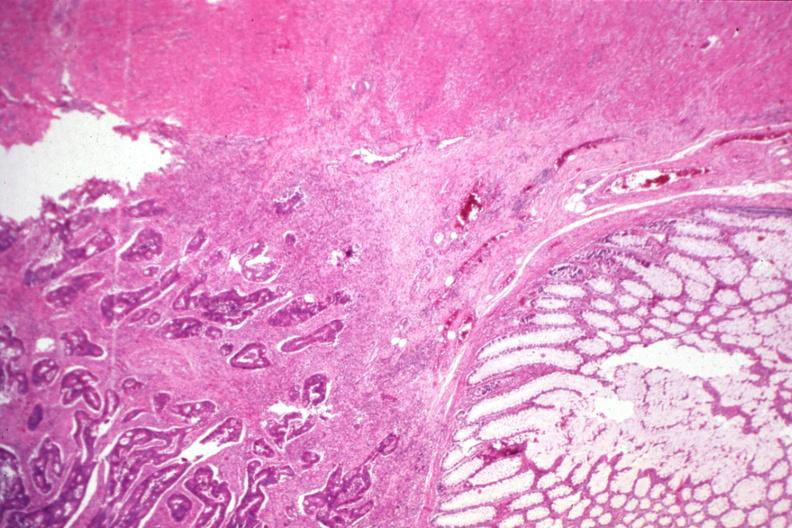does this image show typical infiltrating adenocarcinoma and normal mucosa?
Answer the question using a single word or phrase. Yes 